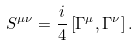<formula> <loc_0><loc_0><loc_500><loc_500>S ^ { \mu \nu } = \frac { i } { 4 } \left [ \Gamma ^ { \mu } , \Gamma ^ { \nu } \right ] .</formula> 